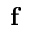<formula> <loc_0><loc_0><loc_500><loc_500>{ f }</formula> 